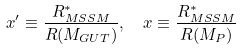Convert formula to latex. <formula><loc_0><loc_0><loc_500><loc_500>x ^ { \prime } \equiv \frac { R _ { M S S M } ^ { * } } { R ( M _ { G U T } ) } , \ \ x \equiv \frac { R _ { M S S M } ^ { * } } { R ( M _ { P } ) }</formula> 